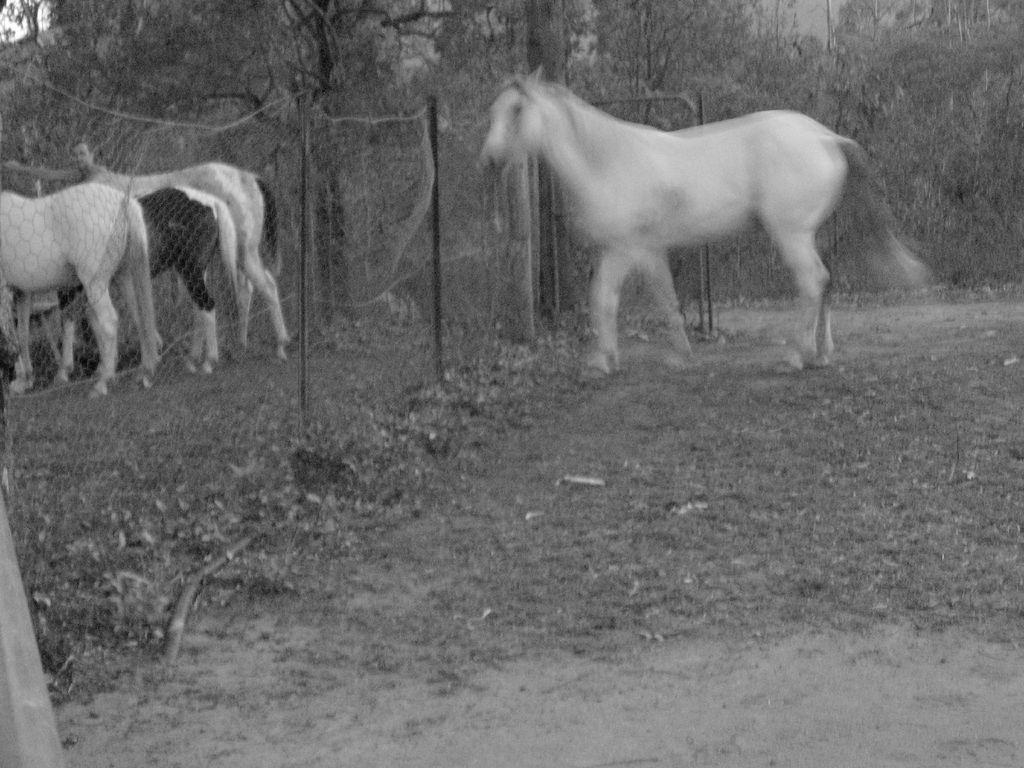Can you describe this image briefly? In the picture we can see a surface with a horse walking near the fencing wall and behind it, we can see some horses are standing and in the background we can see full of trees. 